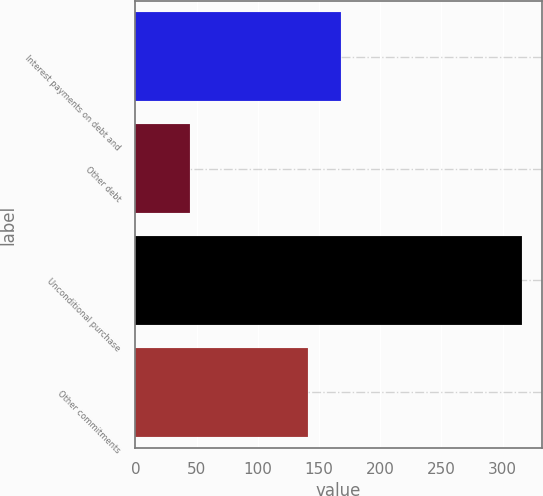Convert chart to OTSL. <chart><loc_0><loc_0><loc_500><loc_500><bar_chart><fcel>Interest payments on debt and<fcel>Other debt<fcel>Unconditional purchase<fcel>Other commitments<nl><fcel>168.1<fcel>45<fcel>316<fcel>141<nl></chart> 